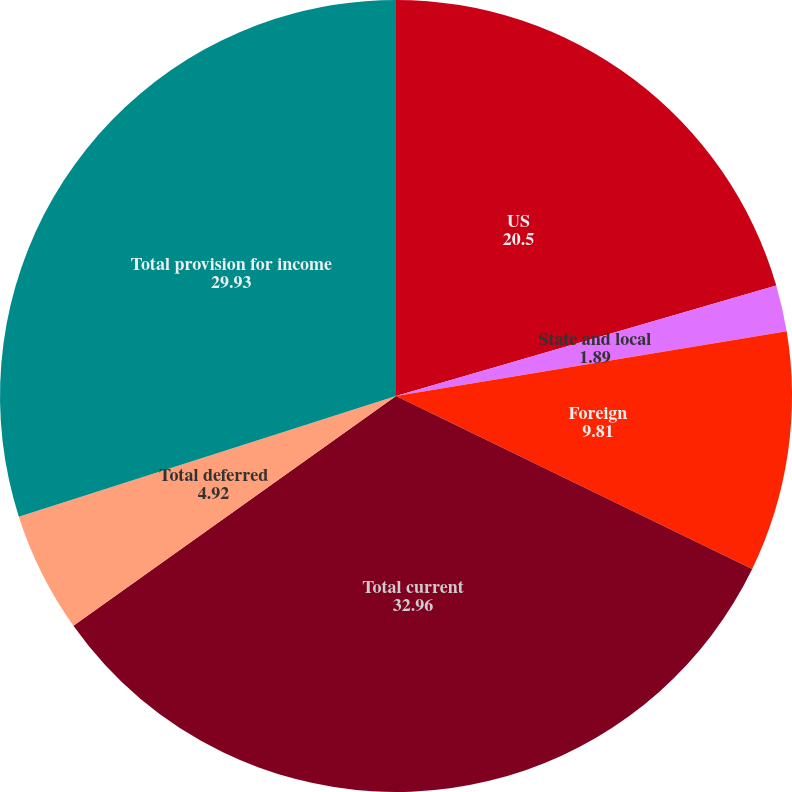Convert chart. <chart><loc_0><loc_0><loc_500><loc_500><pie_chart><fcel>US<fcel>State and local<fcel>Foreign<fcel>Total current<fcel>Total deferred<fcel>Total provision for income<nl><fcel>20.5%<fcel>1.89%<fcel>9.81%<fcel>32.96%<fcel>4.92%<fcel>29.93%<nl></chart> 